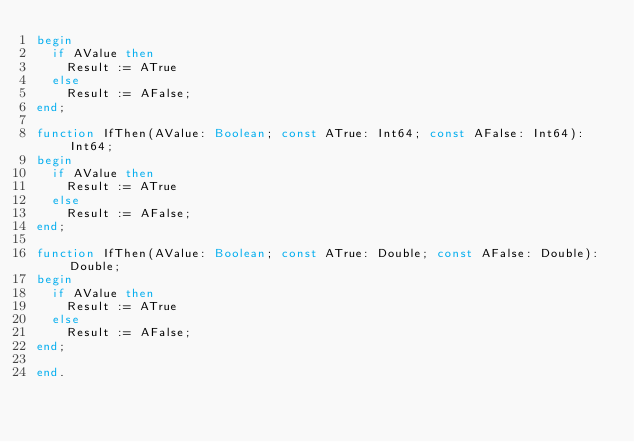<code> <loc_0><loc_0><loc_500><loc_500><_Pascal_>begin
  if AValue then
    Result := ATrue
  else
    Result := AFalse;
end;

function IfThen(AValue: Boolean; const ATrue: Int64; const AFalse: Int64): Int64;
begin
  if AValue then
    Result := ATrue
  else
    Result := AFalse;
end;

function IfThen(AValue: Boolean; const ATrue: Double; const AFalse: Double): Double;
begin
  if AValue then
    Result := ATrue
  else
    Result := AFalse;
end;

end.






</code> 